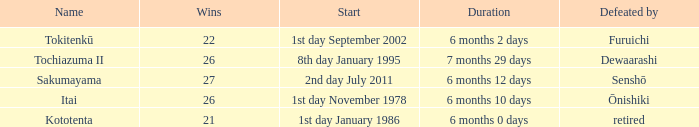How many wins, on average, were defeated by furuichi? 22.0. 